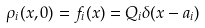<formula> <loc_0><loc_0><loc_500><loc_500>\rho _ { i } ( x , 0 ) = f _ { i } ( x ) = Q _ { i } \delta ( x - a _ { i } )</formula> 